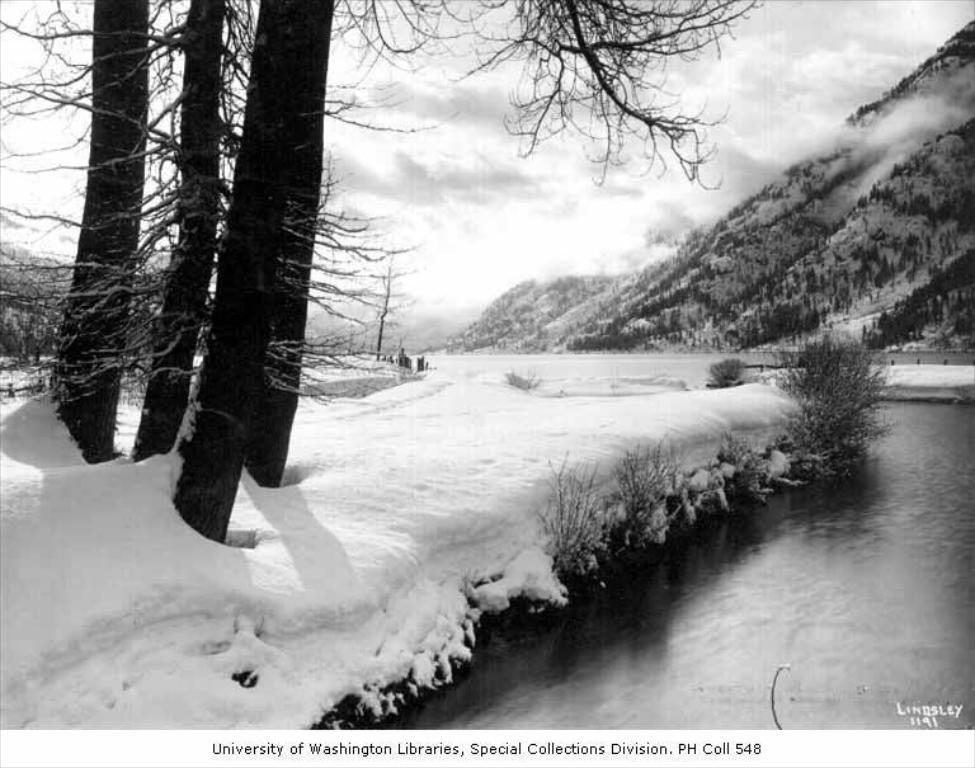Can you describe this image briefly? This is a black and white image. On the right side, I can see the water. On the left side, I can see the snow and there are many trees. In the background there are hills. At the top of the image I can see the sky. At the bottom of this image there is some text. 